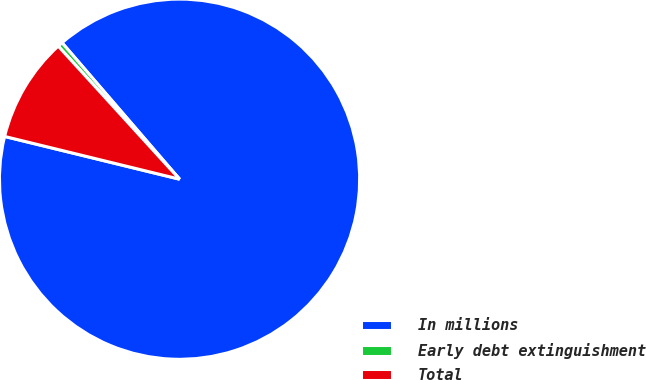<chart> <loc_0><loc_0><loc_500><loc_500><pie_chart><fcel>In millions<fcel>Early debt extinguishment<fcel>Total<nl><fcel>90.14%<fcel>0.45%<fcel>9.42%<nl></chart> 